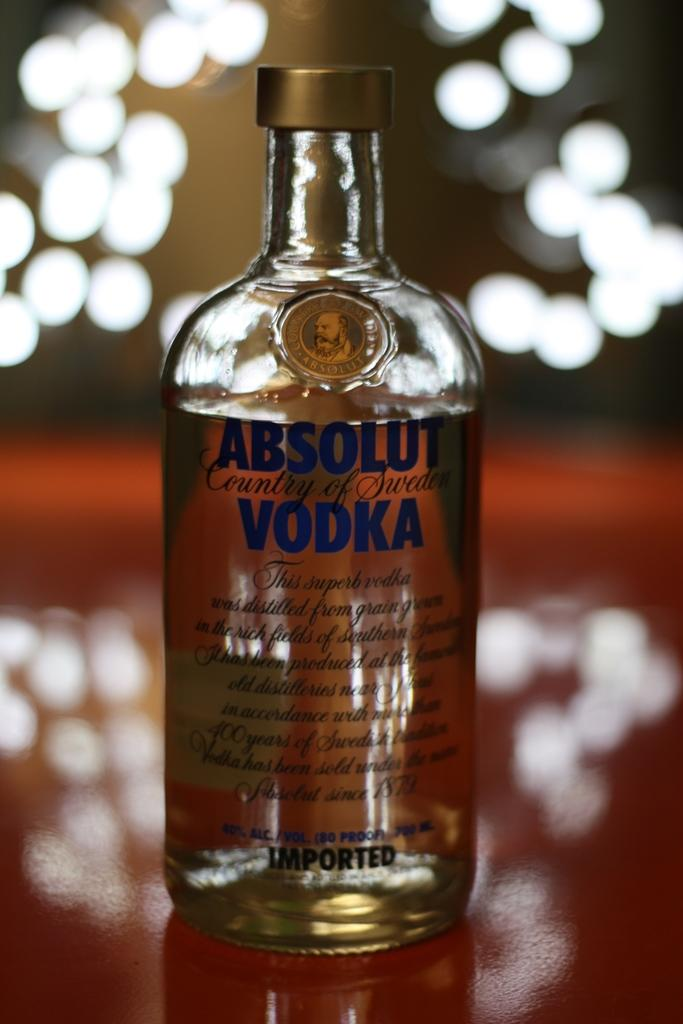What type of alcoholic beverage is featured in the image? There is a vodka bottle in the image. What brand of vodka is shown in the image? The words "Absolut Vodka" are written on the bottle. What type of vase is shown in the image? There is no vase present in the image; it features a vodka bottle. What type of record is playing in the background of the image? There is no record or music playing in the image; it only shows a vodka bottle. 